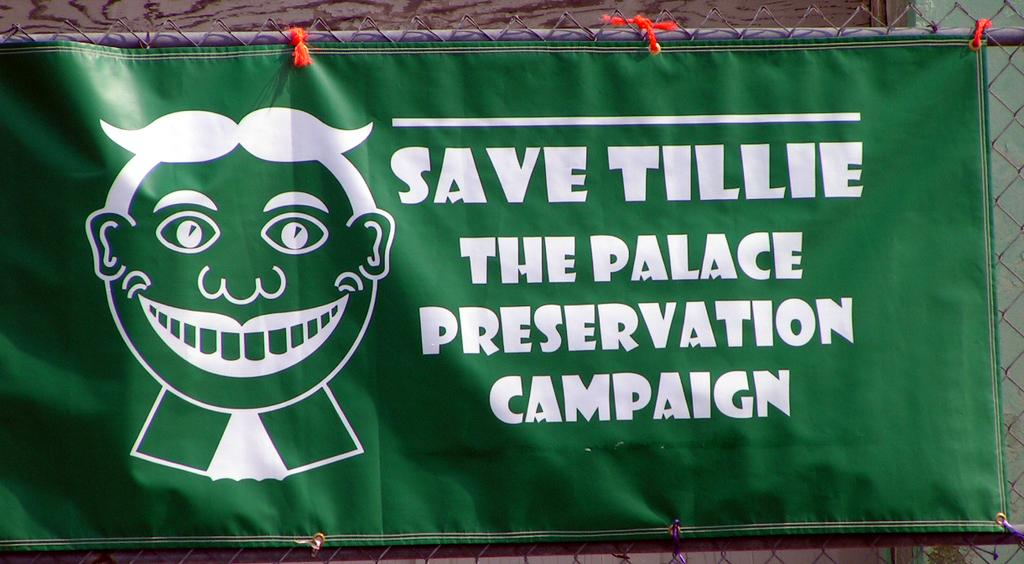What is located in the foreground of the picture? There is a banner in the foreground of the picture. What can be seen on the banner? The banner has text on it. Where is the banner positioned? The banner is on a fencing. What type of pot is being used by the achiever in the image? There is no pot or achiever present in the image; it only features a banner on a fencing. What kind of bread can be seen on the table in the image? There is no bread or table present in the image; it only features a banner on a fencing. 